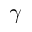Convert formula to latex. <formula><loc_0><loc_0><loc_500><loc_500>\gamma</formula> 